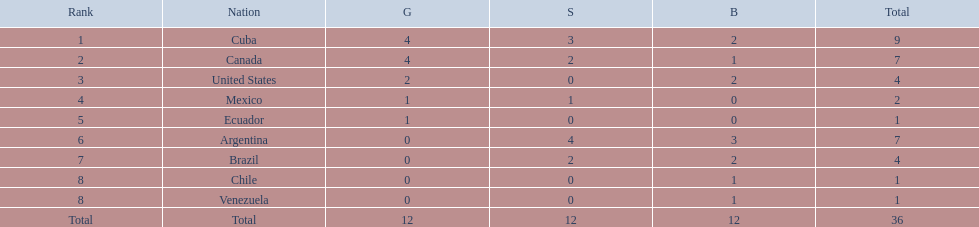Parse the full table. {'header': ['Rank', 'Nation', 'G', 'S', 'B', 'Total'], 'rows': [['1', 'Cuba', '4', '3', '2', '9'], ['2', 'Canada', '4', '2', '1', '7'], ['3', 'United States', '2', '0', '2', '4'], ['4', 'Mexico', '1', '1', '0', '2'], ['5', 'Ecuador', '1', '0', '0', '1'], ['6', 'Argentina', '0', '4', '3', '7'], ['7', 'Brazil', '0', '2', '2', '4'], ['8', 'Chile', '0', '0', '1', '1'], ['8', 'Venezuela', '0', '0', '1', '1'], ['Total', 'Total', '12', '12', '12', '36']]} Which nations won a gold medal in canoeing in the 2011 pan american games? Cuba, Canada, United States, Mexico, Ecuador. Which of these did not win any silver medals? United States. 